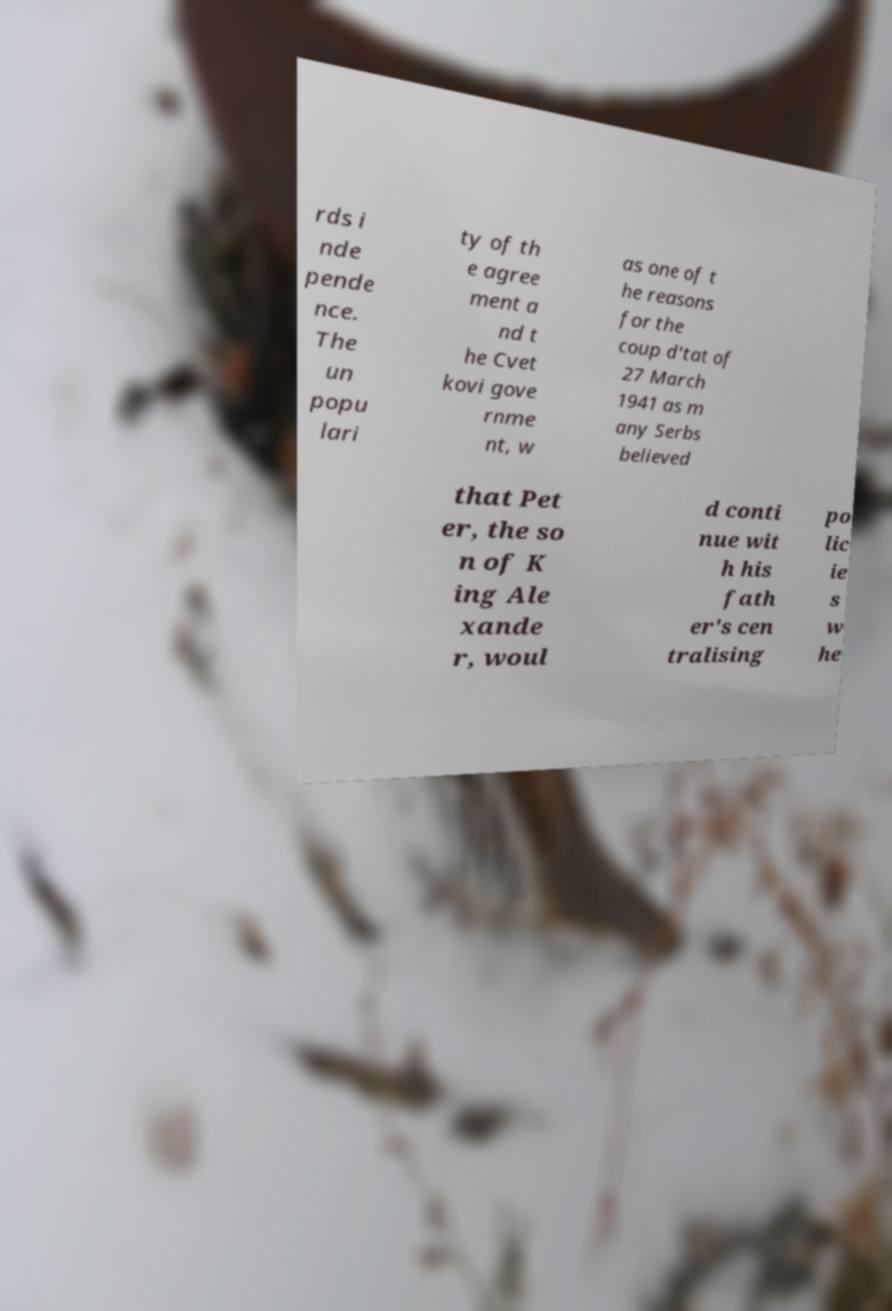I need the written content from this picture converted into text. Can you do that? rds i nde pende nce. The un popu lari ty of th e agree ment a nd t he Cvet kovi gove rnme nt, w as one of t he reasons for the coup d'tat of 27 March 1941 as m any Serbs believed that Pet er, the so n of K ing Ale xande r, woul d conti nue wit h his fath er's cen tralising po lic ie s w he 